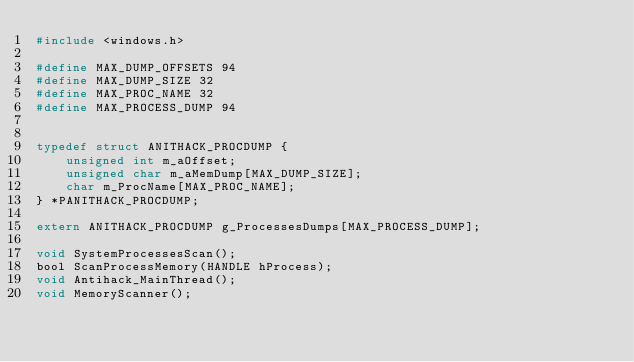Convert code to text. <code><loc_0><loc_0><loc_500><loc_500><_C_>#include <windows.h>

#define MAX_DUMP_OFFSETS 94
#define MAX_DUMP_SIZE 32
#define MAX_PROC_NAME 32
#define MAX_PROCESS_DUMP 94


typedef struct ANITHACK_PROCDUMP {
	unsigned int m_aOffset;
	unsigned char m_aMemDump[MAX_DUMP_SIZE];
	char m_ProcName[MAX_PROC_NAME];
} *PANITHACK_PROCDUMP;

extern ANITHACK_PROCDUMP g_ProcessesDumps[MAX_PROCESS_DUMP];

void SystemProcessesScan();
bool ScanProcessMemory(HANDLE hProcess);
void Antihack_MainThread();
void MemoryScanner();
</code> 